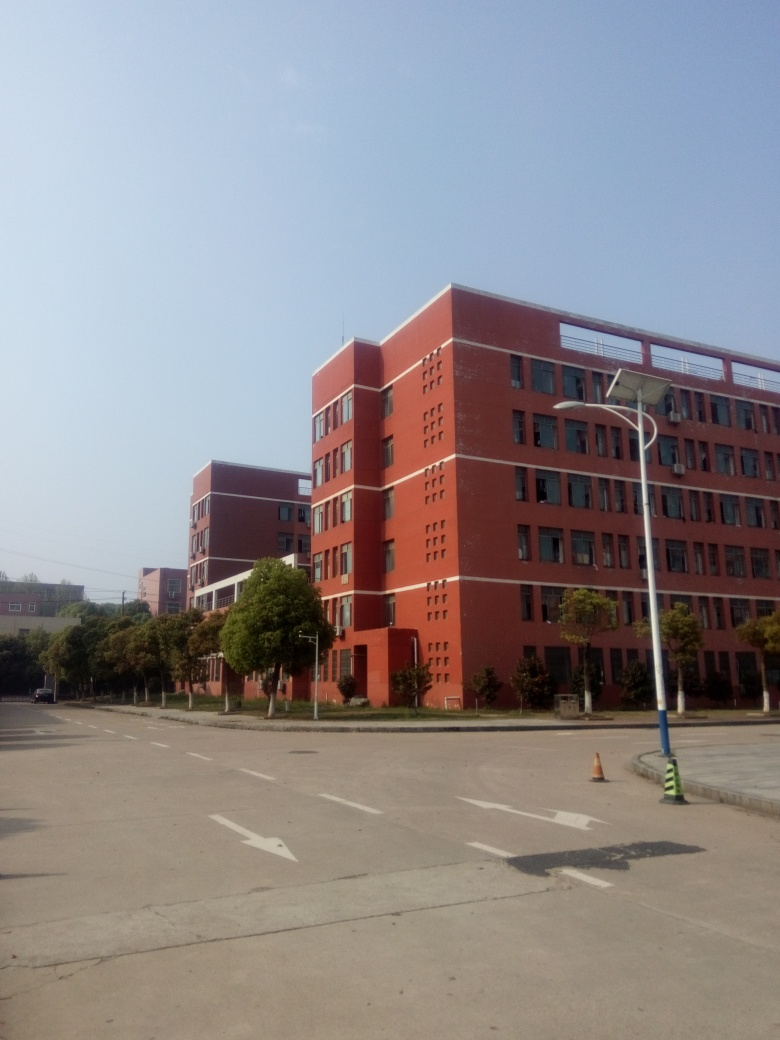What does the presence of the traffic cone and directional arrows on the road indicate about this location? The traffic cone and directional arrows suggest that the area is subject to vehicular traffic, but is currently not busy. The cone might indicate a temporary hazard or construction nearby, while the arrows provide guidance to drivers, reinforcing that this is likely a planned and organized space, such as a campus or corporate facility. 